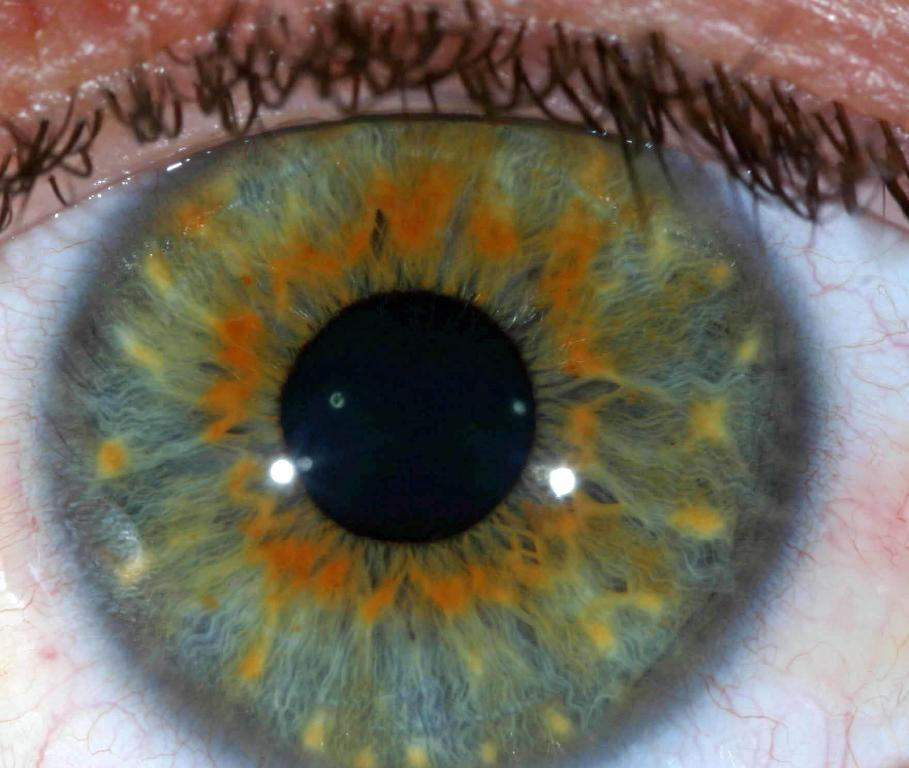What is the main subject of the image? The main subject of the image is an eye and an eyeball. What colors can be seen in the eye? The eye has green, orange, white, and black colors. What part of the eye is visible in the image? The eyelashes are visible in the image. What color are the eyelashes? The eyelashes are black in color. How much profit does the vein in the eye generate in the image? There are no veins present in the image, as it features an eye and its components. 